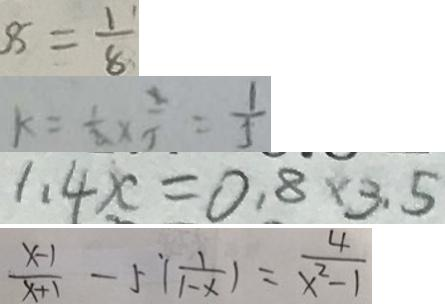Convert formula to latex. <formula><loc_0><loc_0><loc_500><loc_500>8 = \frac { 1 } { 8 } 
 k = \frac { 1 } { 2 } \times \frac { 2 } { 5 } = \frac { 1 } { 5 } 
 1 . 4 x = 0 . 8 \times 3 . 5 
 \frac { x - 1 } { x + 1 } - 5 [ \frac { 1 } { 1 - x } ) = \frac { 4 } { x ^ { 2 } - 1 }</formula> 